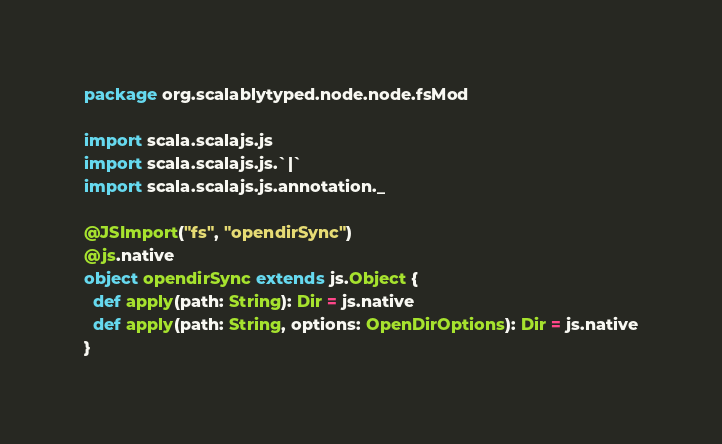Convert code to text. <code><loc_0><loc_0><loc_500><loc_500><_Scala_>package org.scalablytyped.node.node.fsMod

import scala.scalajs.js
import scala.scalajs.js.`|`
import scala.scalajs.js.annotation._

@JSImport("fs", "opendirSync")
@js.native
object opendirSync extends js.Object {
  def apply(path: String): Dir = js.native
  def apply(path: String, options: OpenDirOptions): Dir = js.native
}

</code> 